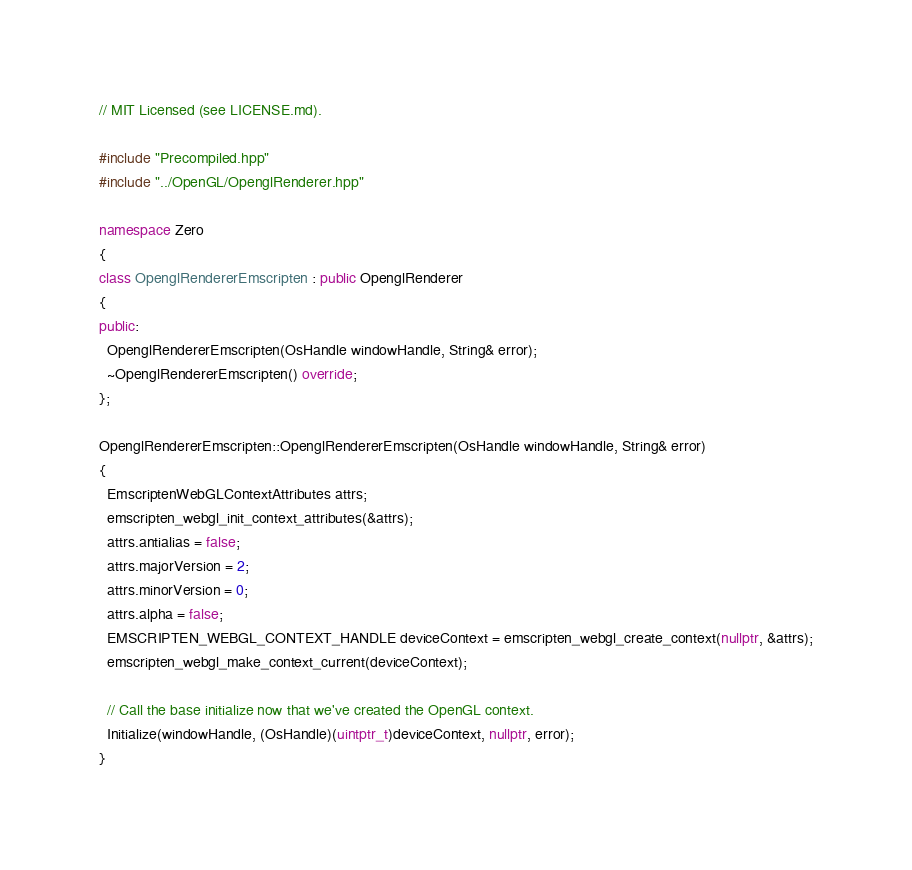<code> <loc_0><loc_0><loc_500><loc_500><_C++_>// MIT Licensed (see LICENSE.md).

#include "Precompiled.hpp"
#include "../OpenGL/OpenglRenderer.hpp"

namespace Zero
{
class OpenglRendererEmscripten : public OpenglRenderer
{
public:
  OpenglRendererEmscripten(OsHandle windowHandle, String& error);
  ~OpenglRendererEmscripten() override;
};

OpenglRendererEmscripten::OpenglRendererEmscripten(OsHandle windowHandle, String& error)
{
  EmscriptenWebGLContextAttributes attrs;
  emscripten_webgl_init_context_attributes(&attrs);
  attrs.antialias = false;
  attrs.majorVersion = 2;
  attrs.minorVersion = 0;
  attrs.alpha = false;
  EMSCRIPTEN_WEBGL_CONTEXT_HANDLE deviceContext = emscripten_webgl_create_context(nullptr, &attrs);
  emscripten_webgl_make_context_current(deviceContext);

  // Call the base initialize now that we've created the OpenGL context.
  Initialize(windowHandle, (OsHandle)(uintptr_t)deviceContext, nullptr, error);
}
</code> 